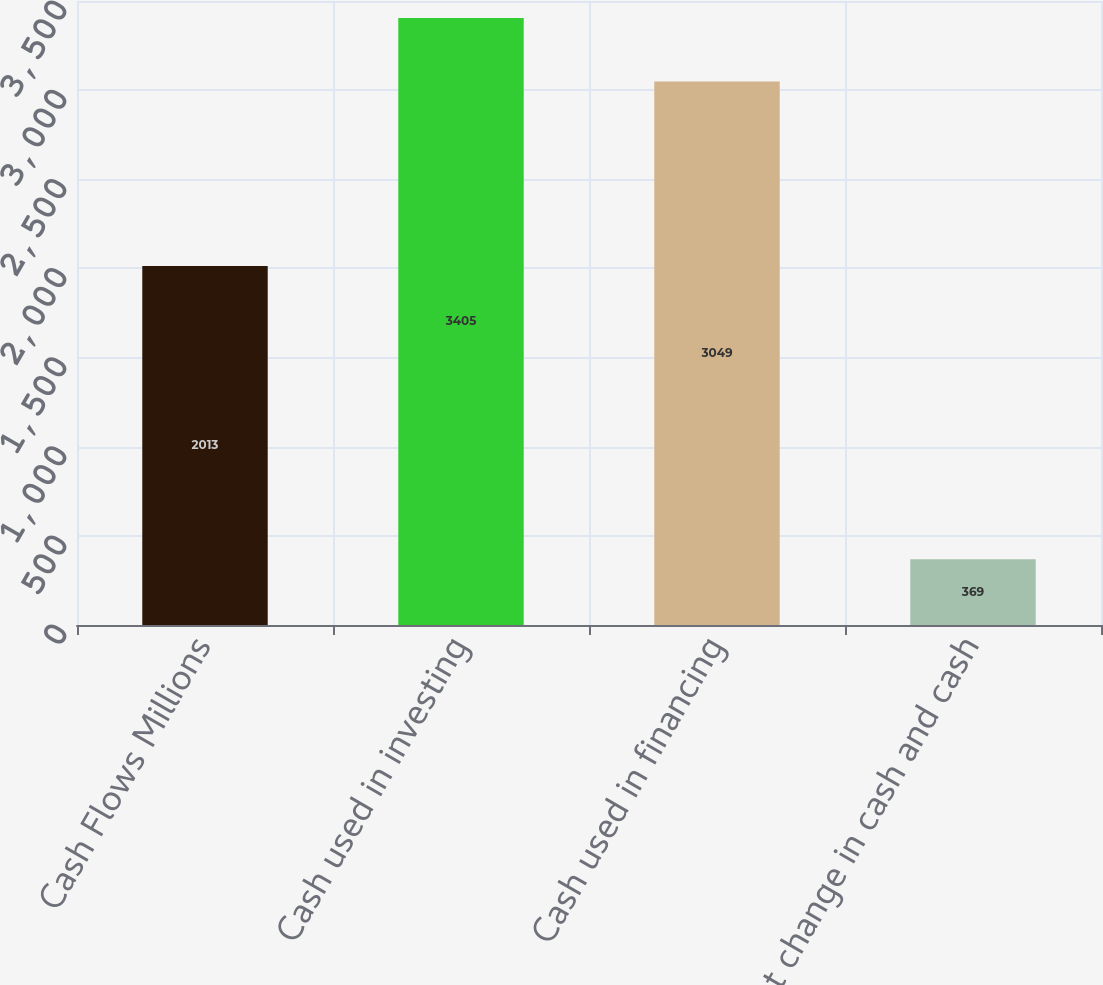Convert chart to OTSL. <chart><loc_0><loc_0><loc_500><loc_500><bar_chart><fcel>Cash Flows Millions<fcel>Cash used in investing<fcel>Cash used in financing<fcel>Net change in cash and cash<nl><fcel>2013<fcel>3405<fcel>3049<fcel>369<nl></chart> 